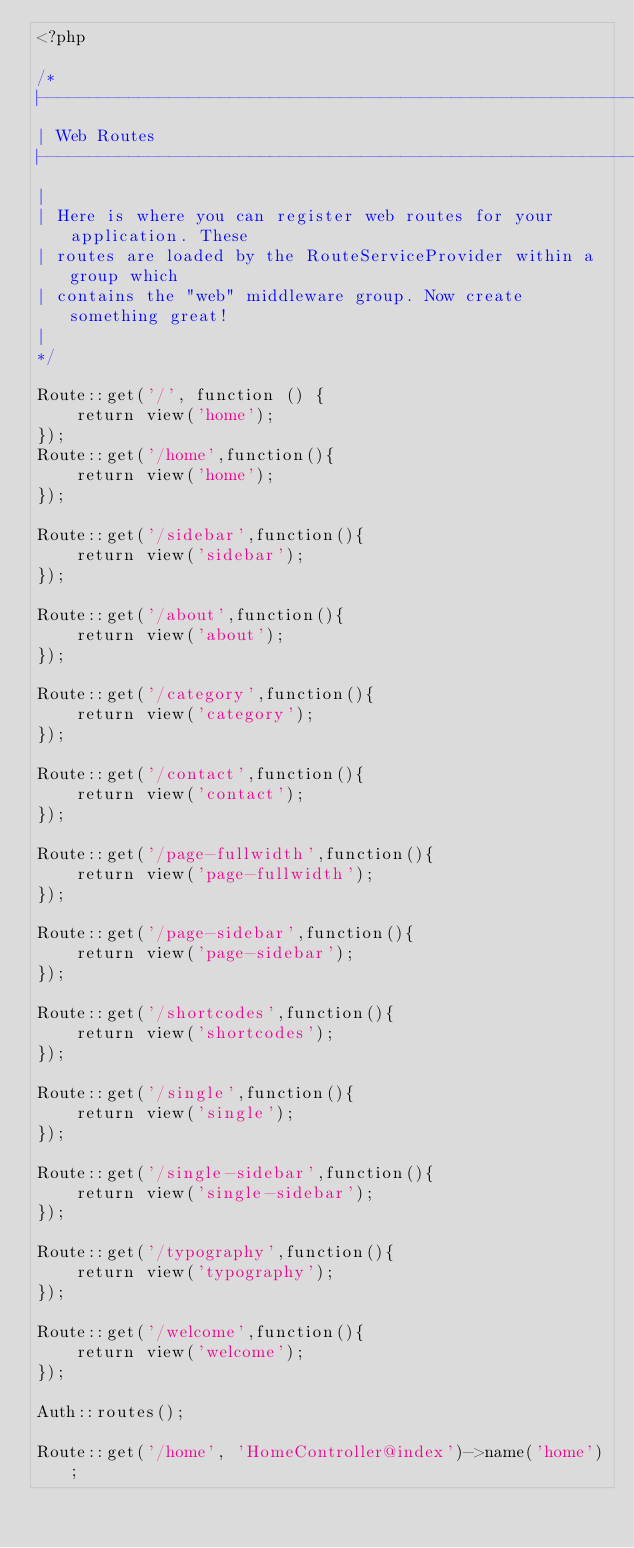Convert code to text. <code><loc_0><loc_0><loc_500><loc_500><_PHP_><?php

/*
|--------------------------------------------------------------------------
| Web Routes
|--------------------------------------------------------------------------
|
| Here is where you can register web routes for your application. These
| routes are loaded by the RouteServiceProvider within a group which
| contains the "web" middleware group. Now create something great!
|
*/

Route::get('/', function () {
    return view('home');
});
Route::get('/home',function(){
    return view('home');
});

Route::get('/sidebar',function(){
    return view('sidebar');
});

Route::get('/about',function(){
    return view('about');
});

Route::get('/category',function(){
    return view('category');
});

Route::get('/contact',function(){
    return view('contact');
});

Route::get('/page-fullwidth',function(){
    return view('page-fullwidth');
});

Route::get('/page-sidebar',function(){
    return view('page-sidebar');
});

Route::get('/shortcodes',function(){
    return view('shortcodes');
});

Route::get('/single',function(){
    return view('single');
});

Route::get('/single-sidebar',function(){
    return view('single-sidebar');
});

Route::get('/typography',function(){
    return view('typography');
});

Route::get('/welcome',function(){
    return view('welcome');
});

Auth::routes();

Route::get('/home', 'HomeController@index')->name('home');
</code> 